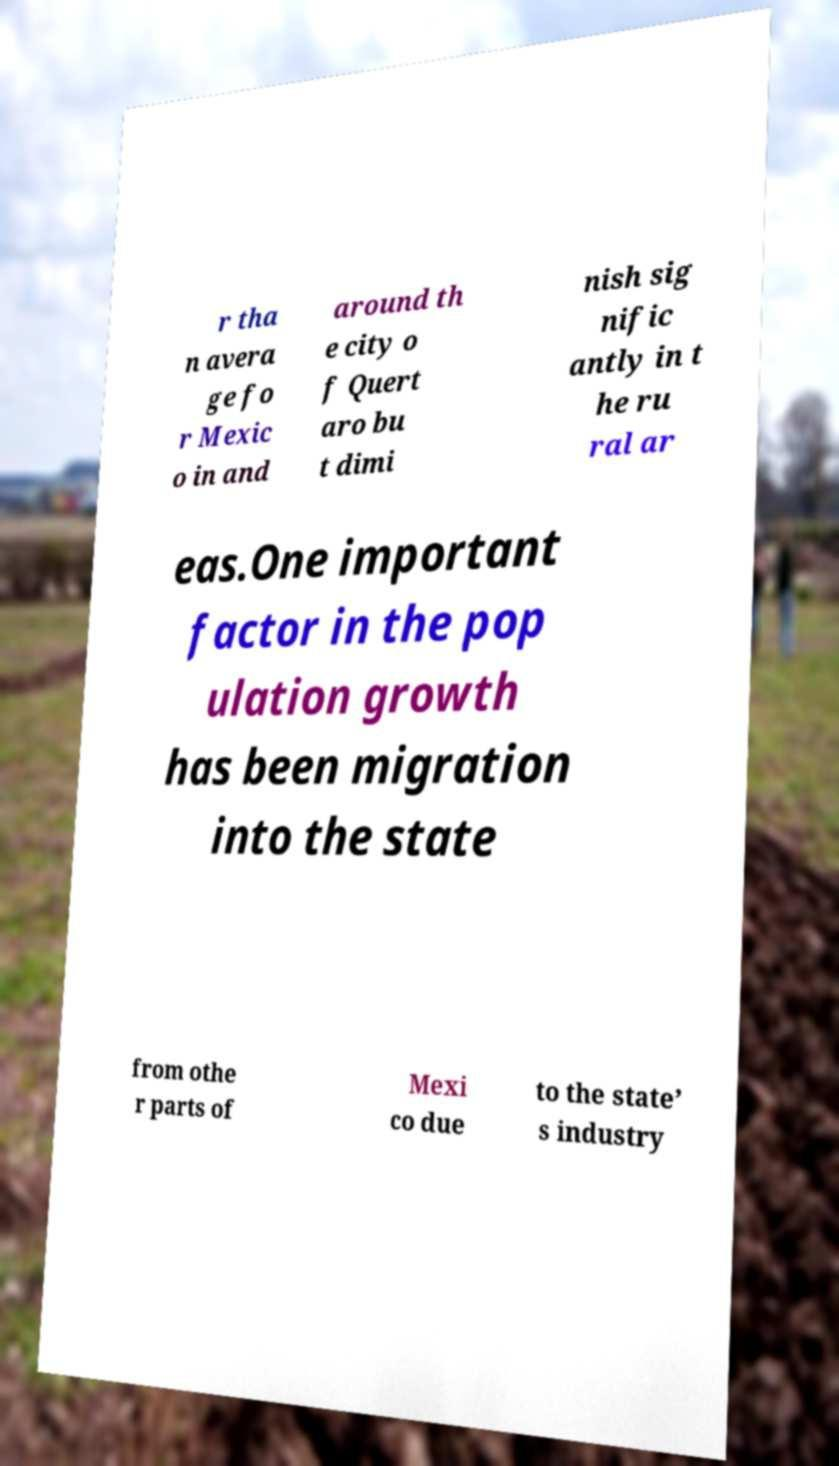Please read and relay the text visible in this image. What does it say? r tha n avera ge fo r Mexic o in and around th e city o f Quert aro bu t dimi nish sig nific antly in t he ru ral ar eas.One important factor in the pop ulation growth has been migration into the state from othe r parts of Mexi co due to the state’ s industry 